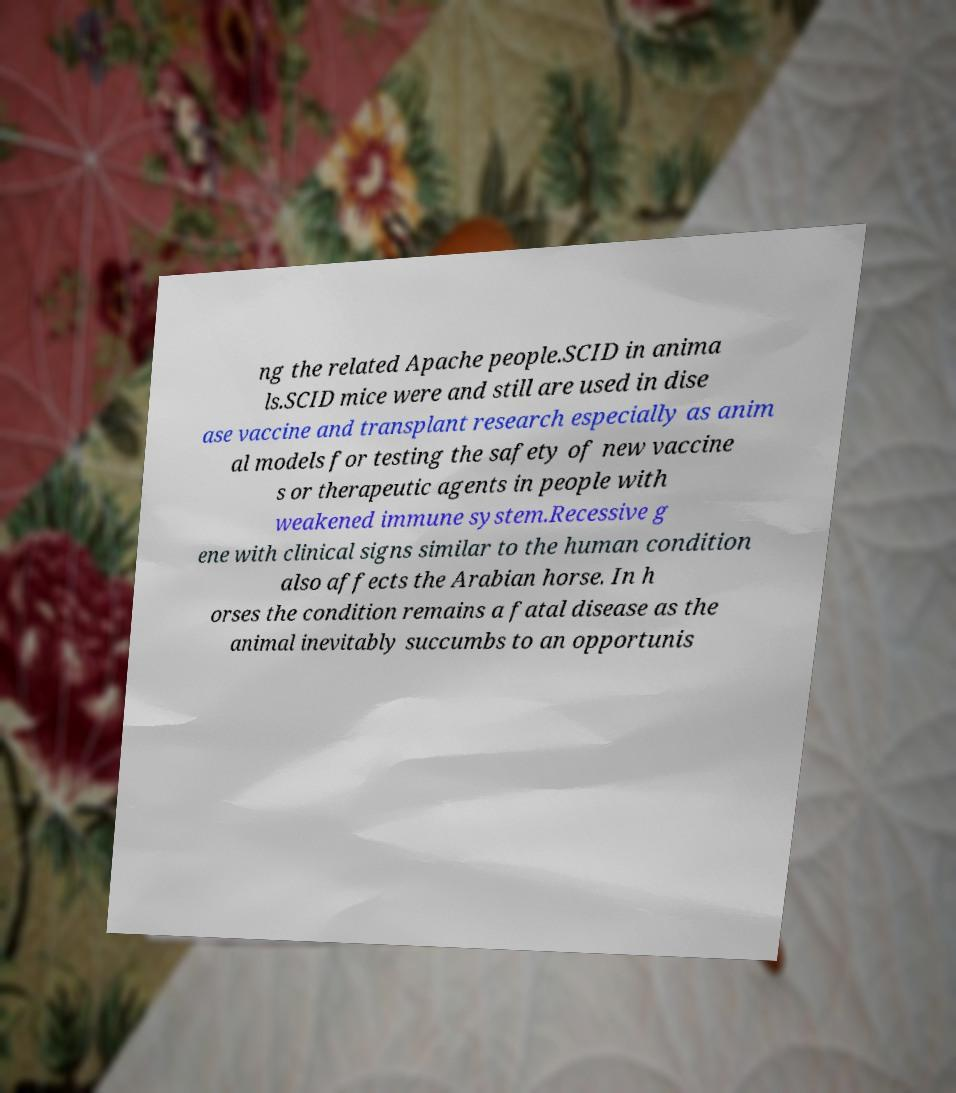For documentation purposes, I need the text within this image transcribed. Could you provide that? ng the related Apache people.SCID in anima ls.SCID mice were and still are used in dise ase vaccine and transplant research especially as anim al models for testing the safety of new vaccine s or therapeutic agents in people with weakened immune system.Recessive g ene with clinical signs similar to the human condition also affects the Arabian horse. In h orses the condition remains a fatal disease as the animal inevitably succumbs to an opportunis 